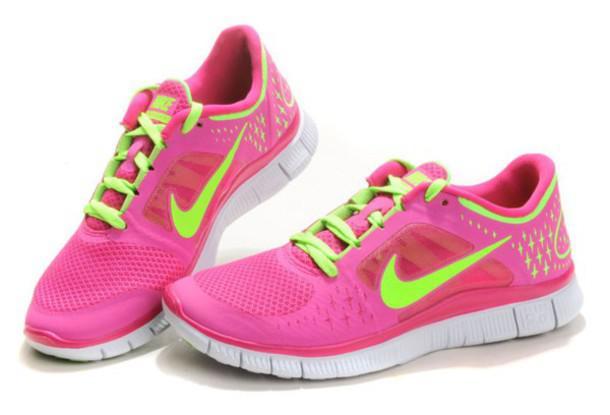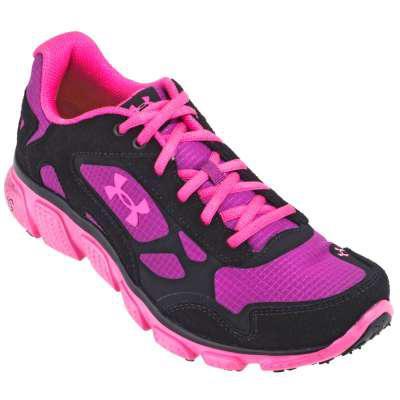The first image is the image on the left, the second image is the image on the right. Examine the images to the left and right. Is the description "The matching pair of shoes faces left." accurate? Answer yes or no. Yes. The first image is the image on the left, the second image is the image on the right. For the images displayed, is the sentence "There are three total shoes in the pair." factually correct? Answer yes or no. Yes. 